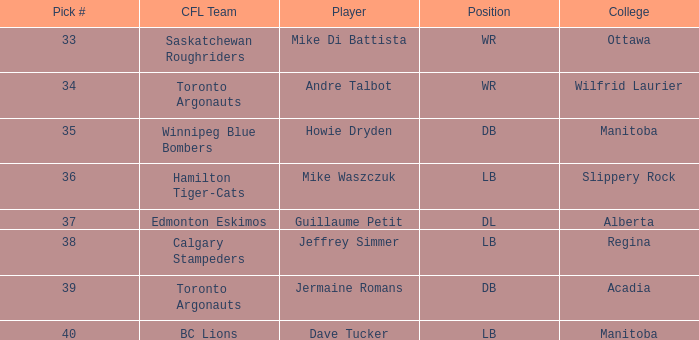What sportsman attends a university in alberta? Guillaume Petit. 